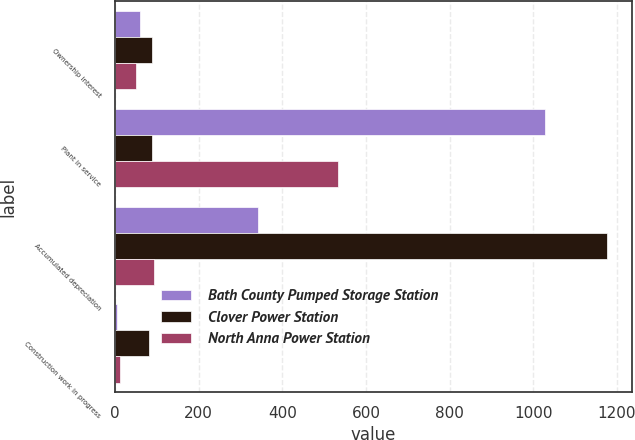Convert chart to OTSL. <chart><loc_0><loc_0><loc_500><loc_500><stacked_bar_chart><ecel><fcel>Ownership interest<fcel>Plant in service<fcel>Accumulated depreciation<fcel>Construction work in progress<nl><fcel>Bath County Pumped Storage Station<fcel>60<fcel>1028<fcel>342<fcel>4<nl><fcel>Clover Power Station<fcel>88.4<fcel>88.4<fcel>1176<fcel>82<nl><fcel>North Anna Power Station<fcel>50<fcel>534<fcel>93<fcel>12<nl></chart> 